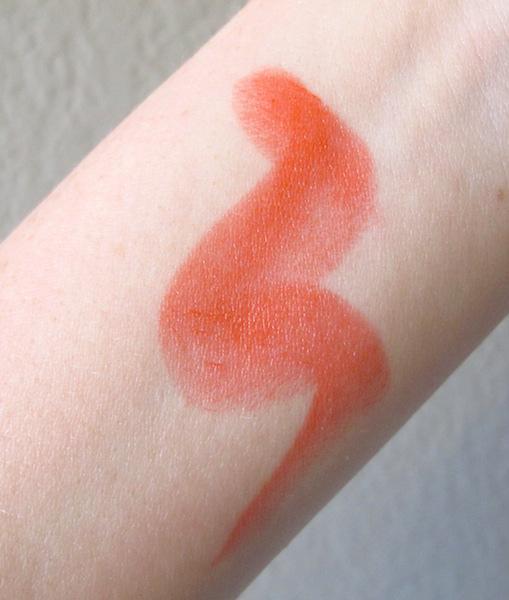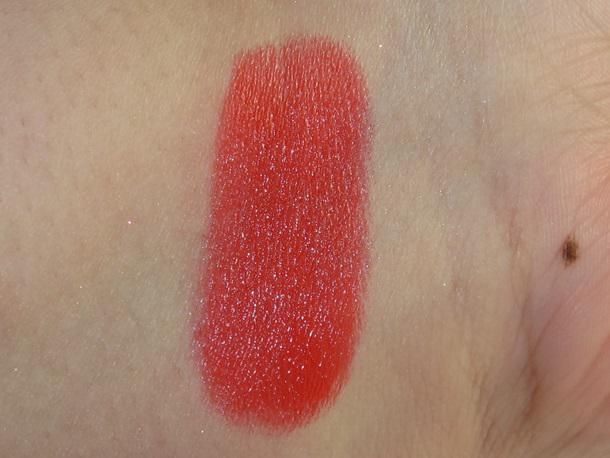The first image is the image on the left, the second image is the image on the right. For the images displayed, is the sentence "There is one lipstick mark across the person's skin on the image on the right." factually correct? Answer yes or no. Yes. The first image is the image on the left, the second image is the image on the right. Examine the images to the left and right. Is the description "One image includes tinted lips, and the other shows a color sample on skin." accurate? Answer yes or no. No. 